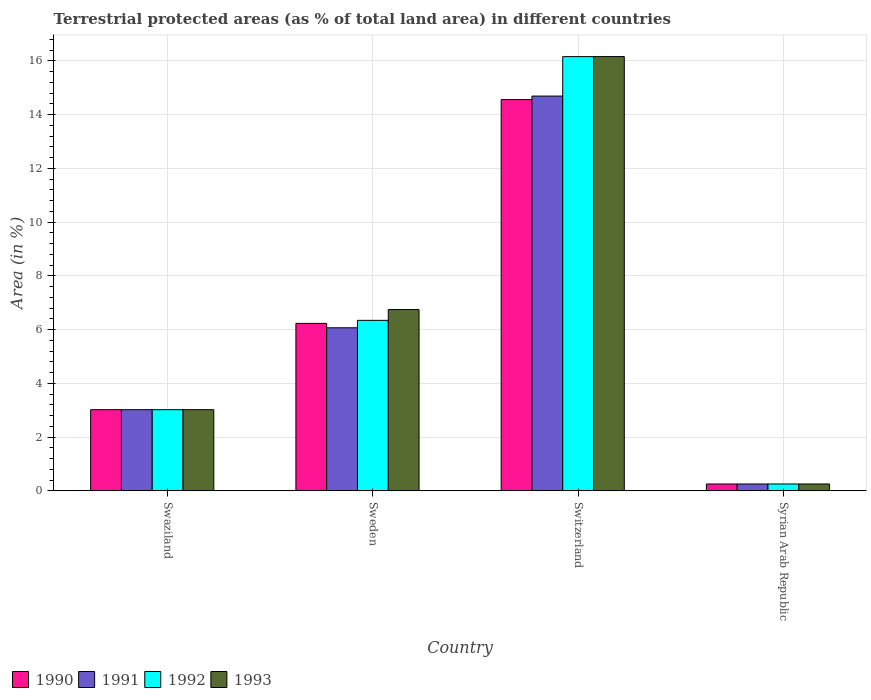How many different coloured bars are there?
Your answer should be very brief. 4. Are the number of bars per tick equal to the number of legend labels?
Ensure brevity in your answer.  Yes. Are the number of bars on each tick of the X-axis equal?
Offer a terse response. Yes. How many bars are there on the 2nd tick from the left?
Offer a very short reply. 4. How many bars are there on the 2nd tick from the right?
Your answer should be compact. 4. What is the percentage of terrestrial protected land in 1992 in Swaziland?
Provide a short and direct response. 3.02. Across all countries, what is the maximum percentage of terrestrial protected land in 1990?
Your answer should be compact. 14.56. Across all countries, what is the minimum percentage of terrestrial protected land in 1990?
Your answer should be very brief. 0.25. In which country was the percentage of terrestrial protected land in 1992 maximum?
Offer a terse response. Switzerland. In which country was the percentage of terrestrial protected land in 1992 minimum?
Make the answer very short. Syrian Arab Republic. What is the total percentage of terrestrial protected land in 1991 in the graph?
Offer a terse response. 24.03. What is the difference between the percentage of terrestrial protected land in 1991 in Sweden and that in Switzerland?
Your answer should be very brief. -8.62. What is the difference between the percentage of terrestrial protected land in 1991 in Switzerland and the percentage of terrestrial protected land in 1993 in Sweden?
Your answer should be very brief. 7.94. What is the average percentage of terrestrial protected land in 1990 per country?
Give a very brief answer. 6.02. What is the difference between the percentage of terrestrial protected land of/in 1990 and percentage of terrestrial protected land of/in 1991 in Swaziland?
Offer a very short reply. 1.0386087440306113e-5. What is the ratio of the percentage of terrestrial protected land in 1993 in Sweden to that in Switzerland?
Offer a very short reply. 0.42. Is the percentage of terrestrial protected land in 1991 in Sweden less than that in Switzerland?
Provide a succinct answer. Yes. Is the difference between the percentage of terrestrial protected land in 1990 in Switzerland and Syrian Arab Republic greater than the difference between the percentage of terrestrial protected land in 1991 in Switzerland and Syrian Arab Republic?
Your response must be concise. No. What is the difference between the highest and the second highest percentage of terrestrial protected land in 1992?
Offer a terse response. 13.14. What is the difference between the highest and the lowest percentage of terrestrial protected land in 1991?
Your response must be concise. 14.44. Is it the case that in every country, the sum of the percentage of terrestrial protected land in 1991 and percentage of terrestrial protected land in 1993 is greater than the sum of percentage of terrestrial protected land in 1992 and percentage of terrestrial protected land in 1990?
Your response must be concise. No. How many bars are there?
Your answer should be very brief. 16. Are all the bars in the graph horizontal?
Your answer should be compact. No. How many countries are there in the graph?
Ensure brevity in your answer.  4. Are the values on the major ticks of Y-axis written in scientific E-notation?
Give a very brief answer. No. Does the graph contain any zero values?
Offer a very short reply. No. What is the title of the graph?
Offer a terse response. Terrestrial protected areas (as % of total land area) in different countries. Does "1982" appear as one of the legend labels in the graph?
Provide a short and direct response. No. What is the label or title of the X-axis?
Your answer should be compact. Country. What is the label or title of the Y-axis?
Provide a succinct answer. Area (in %). What is the Area (in %) in 1990 in Swaziland?
Make the answer very short. 3.02. What is the Area (in %) of 1991 in Swaziland?
Keep it short and to the point. 3.02. What is the Area (in %) in 1992 in Swaziland?
Provide a succinct answer. 3.02. What is the Area (in %) in 1993 in Swaziland?
Give a very brief answer. 3.02. What is the Area (in %) in 1990 in Sweden?
Offer a terse response. 6.23. What is the Area (in %) in 1991 in Sweden?
Your answer should be very brief. 6.07. What is the Area (in %) of 1992 in Sweden?
Your answer should be very brief. 6.34. What is the Area (in %) in 1993 in Sweden?
Your answer should be compact. 6.75. What is the Area (in %) of 1990 in Switzerland?
Provide a short and direct response. 14.56. What is the Area (in %) in 1991 in Switzerland?
Your answer should be compact. 14.69. What is the Area (in %) in 1992 in Switzerland?
Offer a terse response. 16.16. What is the Area (in %) in 1993 in Switzerland?
Provide a succinct answer. 16.16. What is the Area (in %) in 1990 in Syrian Arab Republic?
Give a very brief answer. 0.25. What is the Area (in %) in 1991 in Syrian Arab Republic?
Offer a terse response. 0.25. What is the Area (in %) in 1992 in Syrian Arab Republic?
Your answer should be very brief. 0.25. What is the Area (in %) in 1993 in Syrian Arab Republic?
Provide a short and direct response. 0.25. Across all countries, what is the maximum Area (in %) in 1990?
Give a very brief answer. 14.56. Across all countries, what is the maximum Area (in %) of 1991?
Keep it short and to the point. 14.69. Across all countries, what is the maximum Area (in %) in 1992?
Ensure brevity in your answer.  16.16. Across all countries, what is the maximum Area (in %) in 1993?
Your answer should be compact. 16.16. Across all countries, what is the minimum Area (in %) of 1990?
Keep it short and to the point. 0.25. Across all countries, what is the minimum Area (in %) of 1991?
Offer a very short reply. 0.25. Across all countries, what is the minimum Area (in %) in 1992?
Give a very brief answer. 0.25. Across all countries, what is the minimum Area (in %) in 1993?
Give a very brief answer. 0.25. What is the total Area (in %) in 1990 in the graph?
Your answer should be compact. 24.06. What is the total Area (in %) in 1991 in the graph?
Provide a succinct answer. 24.03. What is the total Area (in %) of 1992 in the graph?
Provide a short and direct response. 25.77. What is the total Area (in %) in 1993 in the graph?
Give a very brief answer. 26.18. What is the difference between the Area (in %) of 1990 in Swaziland and that in Sweden?
Offer a terse response. -3.21. What is the difference between the Area (in %) of 1991 in Swaziland and that in Sweden?
Provide a succinct answer. -3.05. What is the difference between the Area (in %) in 1992 in Swaziland and that in Sweden?
Offer a terse response. -3.32. What is the difference between the Area (in %) in 1993 in Swaziland and that in Sweden?
Provide a short and direct response. -3.73. What is the difference between the Area (in %) of 1990 in Swaziland and that in Switzerland?
Ensure brevity in your answer.  -11.54. What is the difference between the Area (in %) in 1991 in Swaziland and that in Switzerland?
Provide a short and direct response. -11.67. What is the difference between the Area (in %) in 1992 in Swaziland and that in Switzerland?
Ensure brevity in your answer.  -13.14. What is the difference between the Area (in %) in 1993 in Swaziland and that in Switzerland?
Ensure brevity in your answer.  -13.14. What is the difference between the Area (in %) of 1990 in Swaziland and that in Syrian Arab Republic?
Offer a very short reply. 2.77. What is the difference between the Area (in %) in 1991 in Swaziland and that in Syrian Arab Republic?
Keep it short and to the point. 2.77. What is the difference between the Area (in %) in 1992 in Swaziland and that in Syrian Arab Republic?
Ensure brevity in your answer.  2.77. What is the difference between the Area (in %) of 1993 in Swaziland and that in Syrian Arab Republic?
Give a very brief answer. 2.77. What is the difference between the Area (in %) in 1990 in Sweden and that in Switzerland?
Provide a short and direct response. -8.33. What is the difference between the Area (in %) in 1991 in Sweden and that in Switzerland?
Offer a terse response. -8.62. What is the difference between the Area (in %) of 1992 in Sweden and that in Switzerland?
Provide a short and direct response. -9.82. What is the difference between the Area (in %) in 1993 in Sweden and that in Switzerland?
Offer a terse response. -9.41. What is the difference between the Area (in %) of 1990 in Sweden and that in Syrian Arab Republic?
Provide a succinct answer. 5.98. What is the difference between the Area (in %) in 1991 in Sweden and that in Syrian Arab Republic?
Make the answer very short. 5.81. What is the difference between the Area (in %) of 1992 in Sweden and that in Syrian Arab Republic?
Your answer should be very brief. 6.09. What is the difference between the Area (in %) in 1993 in Sweden and that in Syrian Arab Republic?
Your response must be concise. 6.49. What is the difference between the Area (in %) in 1990 in Switzerland and that in Syrian Arab Republic?
Your response must be concise. 14.31. What is the difference between the Area (in %) of 1991 in Switzerland and that in Syrian Arab Republic?
Give a very brief answer. 14.44. What is the difference between the Area (in %) in 1992 in Switzerland and that in Syrian Arab Republic?
Your answer should be compact. 15.9. What is the difference between the Area (in %) in 1993 in Switzerland and that in Syrian Arab Republic?
Offer a terse response. 15.91. What is the difference between the Area (in %) in 1990 in Swaziland and the Area (in %) in 1991 in Sweden?
Ensure brevity in your answer.  -3.05. What is the difference between the Area (in %) in 1990 in Swaziland and the Area (in %) in 1992 in Sweden?
Offer a terse response. -3.32. What is the difference between the Area (in %) of 1990 in Swaziland and the Area (in %) of 1993 in Sweden?
Provide a succinct answer. -3.73. What is the difference between the Area (in %) of 1991 in Swaziland and the Area (in %) of 1992 in Sweden?
Offer a terse response. -3.32. What is the difference between the Area (in %) of 1991 in Swaziland and the Area (in %) of 1993 in Sweden?
Offer a terse response. -3.73. What is the difference between the Area (in %) of 1992 in Swaziland and the Area (in %) of 1993 in Sweden?
Your response must be concise. -3.73. What is the difference between the Area (in %) of 1990 in Swaziland and the Area (in %) of 1991 in Switzerland?
Your answer should be very brief. -11.67. What is the difference between the Area (in %) of 1990 in Swaziland and the Area (in %) of 1992 in Switzerland?
Ensure brevity in your answer.  -13.14. What is the difference between the Area (in %) in 1990 in Swaziland and the Area (in %) in 1993 in Switzerland?
Provide a succinct answer. -13.14. What is the difference between the Area (in %) of 1991 in Swaziland and the Area (in %) of 1992 in Switzerland?
Provide a succinct answer. -13.14. What is the difference between the Area (in %) of 1991 in Swaziland and the Area (in %) of 1993 in Switzerland?
Offer a very short reply. -13.14. What is the difference between the Area (in %) of 1992 in Swaziland and the Area (in %) of 1993 in Switzerland?
Offer a very short reply. -13.14. What is the difference between the Area (in %) of 1990 in Swaziland and the Area (in %) of 1991 in Syrian Arab Republic?
Make the answer very short. 2.77. What is the difference between the Area (in %) in 1990 in Swaziland and the Area (in %) in 1992 in Syrian Arab Republic?
Your answer should be very brief. 2.77. What is the difference between the Area (in %) in 1990 in Swaziland and the Area (in %) in 1993 in Syrian Arab Republic?
Keep it short and to the point. 2.77. What is the difference between the Area (in %) of 1991 in Swaziland and the Area (in %) of 1992 in Syrian Arab Republic?
Make the answer very short. 2.77. What is the difference between the Area (in %) of 1991 in Swaziland and the Area (in %) of 1993 in Syrian Arab Republic?
Keep it short and to the point. 2.77. What is the difference between the Area (in %) of 1992 in Swaziland and the Area (in %) of 1993 in Syrian Arab Republic?
Give a very brief answer. 2.77. What is the difference between the Area (in %) in 1990 in Sweden and the Area (in %) in 1991 in Switzerland?
Your answer should be compact. -8.46. What is the difference between the Area (in %) in 1990 in Sweden and the Area (in %) in 1992 in Switzerland?
Give a very brief answer. -9.93. What is the difference between the Area (in %) in 1990 in Sweden and the Area (in %) in 1993 in Switzerland?
Provide a short and direct response. -9.93. What is the difference between the Area (in %) in 1991 in Sweden and the Area (in %) in 1992 in Switzerland?
Provide a short and direct response. -10.09. What is the difference between the Area (in %) of 1991 in Sweden and the Area (in %) of 1993 in Switzerland?
Give a very brief answer. -10.09. What is the difference between the Area (in %) in 1992 in Sweden and the Area (in %) in 1993 in Switzerland?
Give a very brief answer. -9.82. What is the difference between the Area (in %) in 1990 in Sweden and the Area (in %) in 1991 in Syrian Arab Republic?
Offer a very short reply. 5.98. What is the difference between the Area (in %) in 1990 in Sweden and the Area (in %) in 1992 in Syrian Arab Republic?
Offer a very short reply. 5.98. What is the difference between the Area (in %) in 1990 in Sweden and the Area (in %) in 1993 in Syrian Arab Republic?
Keep it short and to the point. 5.98. What is the difference between the Area (in %) of 1991 in Sweden and the Area (in %) of 1992 in Syrian Arab Republic?
Provide a short and direct response. 5.81. What is the difference between the Area (in %) in 1991 in Sweden and the Area (in %) in 1993 in Syrian Arab Republic?
Provide a short and direct response. 5.81. What is the difference between the Area (in %) of 1992 in Sweden and the Area (in %) of 1993 in Syrian Arab Republic?
Your answer should be compact. 6.09. What is the difference between the Area (in %) in 1990 in Switzerland and the Area (in %) in 1991 in Syrian Arab Republic?
Offer a terse response. 14.31. What is the difference between the Area (in %) of 1990 in Switzerland and the Area (in %) of 1992 in Syrian Arab Republic?
Your answer should be compact. 14.31. What is the difference between the Area (in %) in 1990 in Switzerland and the Area (in %) in 1993 in Syrian Arab Republic?
Provide a succinct answer. 14.31. What is the difference between the Area (in %) in 1991 in Switzerland and the Area (in %) in 1992 in Syrian Arab Republic?
Make the answer very short. 14.44. What is the difference between the Area (in %) of 1991 in Switzerland and the Area (in %) of 1993 in Syrian Arab Republic?
Make the answer very short. 14.44. What is the difference between the Area (in %) in 1992 in Switzerland and the Area (in %) in 1993 in Syrian Arab Republic?
Keep it short and to the point. 15.9. What is the average Area (in %) in 1990 per country?
Your answer should be compact. 6.02. What is the average Area (in %) of 1991 per country?
Provide a succinct answer. 6.01. What is the average Area (in %) in 1992 per country?
Your answer should be very brief. 6.44. What is the average Area (in %) of 1993 per country?
Provide a succinct answer. 6.54. What is the difference between the Area (in %) in 1991 and Area (in %) in 1992 in Swaziland?
Make the answer very short. 0. What is the difference between the Area (in %) of 1990 and Area (in %) of 1991 in Sweden?
Offer a very short reply. 0.16. What is the difference between the Area (in %) in 1990 and Area (in %) in 1992 in Sweden?
Your answer should be very brief. -0.11. What is the difference between the Area (in %) in 1990 and Area (in %) in 1993 in Sweden?
Give a very brief answer. -0.51. What is the difference between the Area (in %) in 1991 and Area (in %) in 1992 in Sweden?
Provide a succinct answer. -0.28. What is the difference between the Area (in %) of 1991 and Area (in %) of 1993 in Sweden?
Provide a short and direct response. -0.68. What is the difference between the Area (in %) in 1992 and Area (in %) in 1993 in Sweden?
Give a very brief answer. -0.4. What is the difference between the Area (in %) of 1990 and Area (in %) of 1991 in Switzerland?
Your answer should be compact. -0.13. What is the difference between the Area (in %) of 1990 and Area (in %) of 1992 in Switzerland?
Provide a succinct answer. -1.6. What is the difference between the Area (in %) in 1990 and Area (in %) in 1993 in Switzerland?
Offer a terse response. -1.6. What is the difference between the Area (in %) in 1991 and Area (in %) in 1992 in Switzerland?
Offer a very short reply. -1.47. What is the difference between the Area (in %) in 1991 and Area (in %) in 1993 in Switzerland?
Your answer should be compact. -1.47. What is the difference between the Area (in %) of 1992 and Area (in %) of 1993 in Switzerland?
Give a very brief answer. -0. What is the difference between the Area (in %) of 1990 and Area (in %) of 1993 in Syrian Arab Republic?
Provide a succinct answer. 0. What is the difference between the Area (in %) of 1991 and Area (in %) of 1992 in Syrian Arab Republic?
Keep it short and to the point. 0. What is the ratio of the Area (in %) of 1990 in Swaziland to that in Sweden?
Ensure brevity in your answer.  0.48. What is the ratio of the Area (in %) in 1991 in Swaziland to that in Sweden?
Ensure brevity in your answer.  0.5. What is the ratio of the Area (in %) of 1992 in Swaziland to that in Sweden?
Keep it short and to the point. 0.48. What is the ratio of the Area (in %) of 1993 in Swaziland to that in Sweden?
Give a very brief answer. 0.45. What is the ratio of the Area (in %) in 1990 in Swaziland to that in Switzerland?
Give a very brief answer. 0.21. What is the ratio of the Area (in %) in 1991 in Swaziland to that in Switzerland?
Ensure brevity in your answer.  0.21. What is the ratio of the Area (in %) in 1992 in Swaziland to that in Switzerland?
Provide a succinct answer. 0.19. What is the ratio of the Area (in %) in 1993 in Swaziland to that in Switzerland?
Offer a terse response. 0.19. What is the ratio of the Area (in %) in 1990 in Swaziland to that in Syrian Arab Republic?
Give a very brief answer. 11.91. What is the ratio of the Area (in %) in 1991 in Swaziland to that in Syrian Arab Republic?
Your answer should be compact. 11.91. What is the ratio of the Area (in %) of 1992 in Swaziland to that in Syrian Arab Republic?
Provide a succinct answer. 11.91. What is the ratio of the Area (in %) of 1993 in Swaziland to that in Syrian Arab Republic?
Provide a succinct answer. 11.91. What is the ratio of the Area (in %) in 1990 in Sweden to that in Switzerland?
Your answer should be compact. 0.43. What is the ratio of the Area (in %) in 1991 in Sweden to that in Switzerland?
Keep it short and to the point. 0.41. What is the ratio of the Area (in %) of 1992 in Sweden to that in Switzerland?
Offer a terse response. 0.39. What is the ratio of the Area (in %) of 1993 in Sweden to that in Switzerland?
Ensure brevity in your answer.  0.42. What is the ratio of the Area (in %) of 1990 in Sweden to that in Syrian Arab Republic?
Offer a very short reply. 24.59. What is the ratio of the Area (in %) of 1991 in Sweden to that in Syrian Arab Republic?
Your answer should be compact. 23.94. What is the ratio of the Area (in %) in 1992 in Sweden to that in Syrian Arab Republic?
Offer a terse response. 25.03. What is the ratio of the Area (in %) in 1993 in Sweden to that in Syrian Arab Republic?
Offer a terse response. 26.62. What is the ratio of the Area (in %) of 1990 in Switzerland to that in Syrian Arab Republic?
Offer a terse response. 57.46. What is the ratio of the Area (in %) in 1991 in Switzerland to that in Syrian Arab Republic?
Your answer should be very brief. 57.98. What is the ratio of the Area (in %) of 1992 in Switzerland to that in Syrian Arab Republic?
Make the answer very short. 63.77. What is the ratio of the Area (in %) of 1993 in Switzerland to that in Syrian Arab Republic?
Keep it short and to the point. 63.78. What is the difference between the highest and the second highest Area (in %) in 1990?
Your answer should be very brief. 8.33. What is the difference between the highest and the second highest Area (in %) in 1991?
Offer a terse response. 8.62. What is the difference between the highest and the second highest Area (in %) of 1992?
Your answer should be very brief. 9.82. What is the difference between the highest and the second highest Area (in %) in 1993?
Offer a very short reply. 9.41. What is the difference between the highest and the lowest Area (in %) in 1990?
Give a very brief answer. 14.31. What is the difference between the highest and the lowest Area (in %) of 1991?
Offer a very short reply. 14.44. What is the difference between the highest and the lowest Area (in %) of 1992?
Ensure brevity in your answer.  15.9. What is the difference between the highest and the lowest Area (in %) in 1993?
Provide a succinct answer. 15.91. 